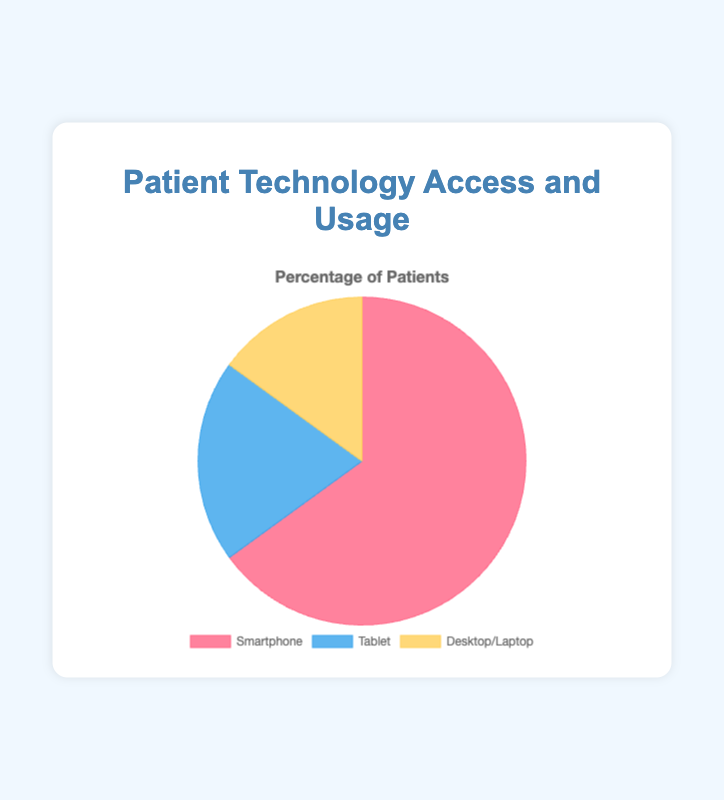What percentage of patients use a smartphone? The pie chart shows the percentage of patients who use different technologies. The segment labeled 'Smartphone' represents 65% of the patients.
Answer: 65% What devices do the remaining 35% of patients use? To find out what devices the remaining patients use, subtract the percentage of smartphone users from 100% (100% - 65% = 35%). The remaining 35% is divided among 'Tablet' and 'Desktop/Laptop'.
Answer: Tablet and Desktop/Laptop Which device is least used by patients? According to the pie chart, the segment for 'Desktop/Laptop' has the smallest percentage, which is 15%.
Answer: Desktop/Laptop How much more common is smartphone usage compared to tablet usage? To find the difference between smartphone and tablet usage, subtract the tablet percentage from the smartphone percentage (65% - 20% = 45%).
Answer: 45% If we combined the percentages of tablet and desktop/laptop users, would it surpass smartphone users? Sum the percentages of tablet and desktop/laptop users (20% + 15% = 35%). Compare this to the smartphone users' percentage (65%). 35% is less than 65%, so it wouldn't surpass.
Answer: No What is the total percentage of patients using either smartphones or tablets? Add the percentages of smartphone users and tablet users (65% + 20% = 85%).
Answer: 85% What color represents tablet users in the chart? The pie chart uses different colors for each segment. The segment for 'Tablet' is in blue.
Answer: Blue Is desktop/laptop usage more or less than half of tablet usage? To determine this, find half of the tablet usage (20% / 2 = 10%) and compare it to desktop/laptop usage (15%). Since 15% is more than 10%, desktop/laptop usage is more than half of tablet usage.
Answer: More Which device color segment appears the smallest in the chart? Based on the pie chart visual, the smallest segment in terms of size represents 'Desktop/Laptop', which is shown in yellow.
Answer: Yellow How much greater is the usage of smartphones compared to the combined usage of tablets and desktops/laptops? First, find the combined usage of tablets and desktops/laptops (20% + 15% = 35%). Then, subtract this from smartphone usage (65% - 35% = 30%).
Answer: 30% 